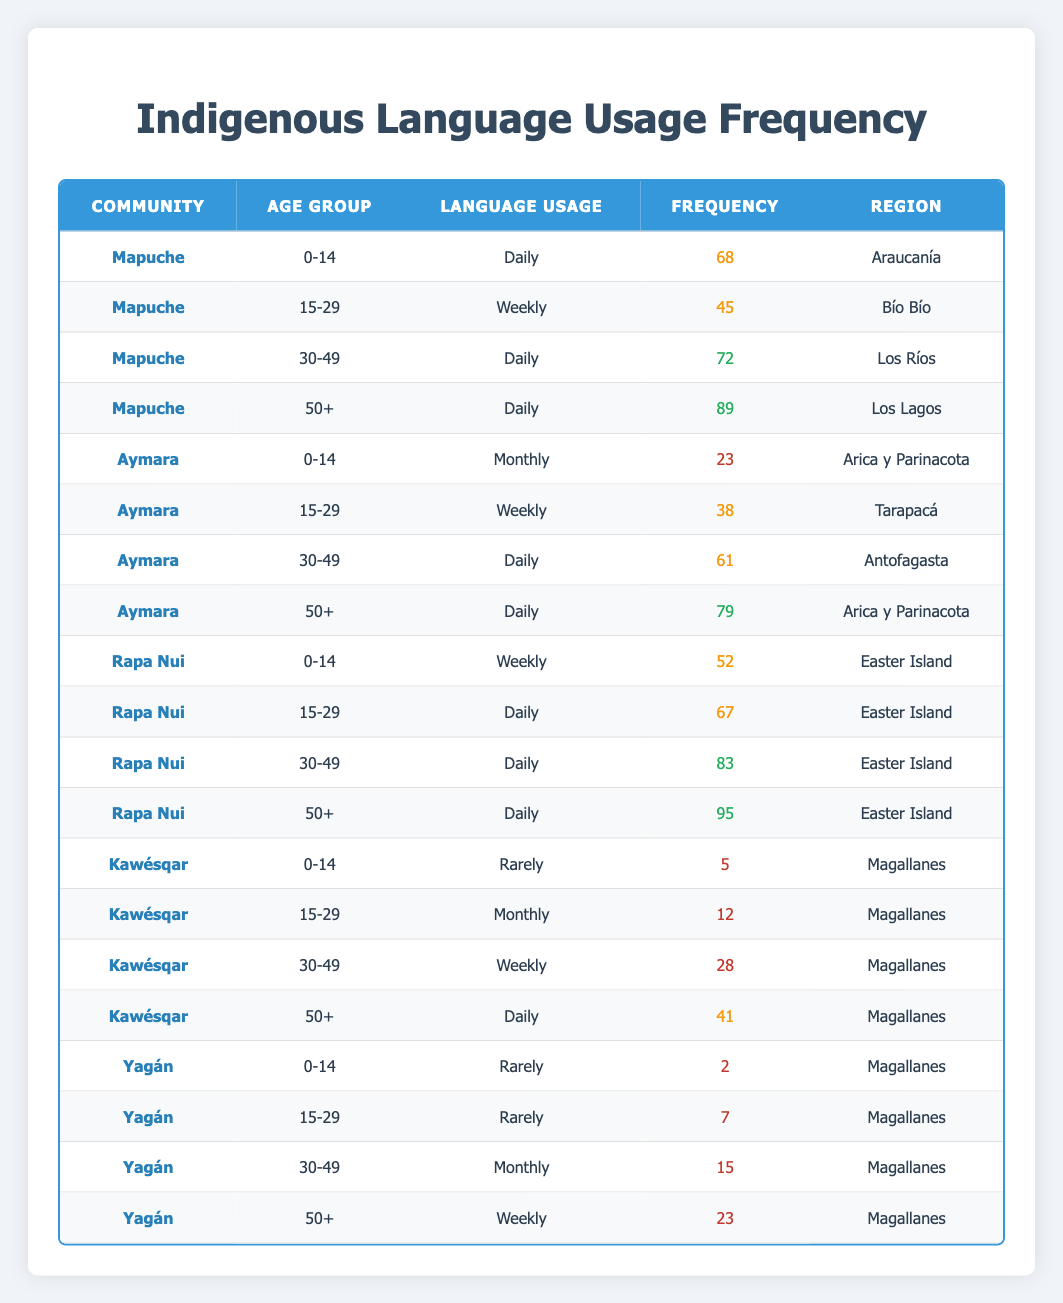What is the language usage frequency for the Mapuche community in the age group 15-29? The Mapuche community, in the age group 15-29, has a language usage frequency labeled as "Weekly," which can be directly seen in the table.
Answer: Weekly How many members of the Rapa Nui community aged 50+ use their language daily? In the table, the Rapa Nui community's data shows that people aged 50+ use their language with a frequency of 95. This means 95 members use their language daily.
Answer: 95 Which age group has the highest language usage frequency in the Aymara community? The Aymara community shows the highest frequency in the age group 50+ with a frequency of 79, compared to 61 in 30-49, 38 in 15-29, and 23 in 0-14. Thus, the highest frequency is in the 50+ age group.
Answer: 50+ What is the average frequency of language usage for the Yagán community? To find the average frequency, add the frequencies (2 + 7 + 15 + 23 = 47) and divide by the number of age groups (4). So, the average frequency is 47 / 4 = 11.75.
Answer: 11.75 Is there any age group in the Kawésqar community that uses their language daily? The table shows that only the age group 50+ uses their language daily in the Kawésqar community, which has a frequency of 41. Thus, the statement is true.
Answer: Yes What is the total frequency of language usage for the Mapuche community across all age groups? Add the frequencies for the Mapuche community: (68 + 45 + 72 + 89) = 274. Thus, the total frequency is 274.
Answer: 274 Which community has the lowest language usage frequency for the age group 0-14? In the age group 0-14, the Kawésqar community has a frequency of 5, while the Yagán community has a frequency of 2. The Yagán community has the lowest usage frequency in this age group.
Answer: Yagán What percentage of the total frequency for the Rapa Nui community is represented by the age group 30-49? The total frequency for Rapa Nui is calculated by adding the frequencies: (52 + 67 + 83 + 95 = 297). The frequency for the 30-49 age group is 83. To find the percentage, (83 / 297) * 100 = approximately 27.94%.
Answer: 27.94% What is the difference in language usage frequency between the 0-14 age group in Mapuche and Aymara communities? The frequency for the Mapuche community in the 0-14 age group is 68, while for the Aymara, it is 23. The difference is calculated as 68 - 23 = 45.
Answer: 45 